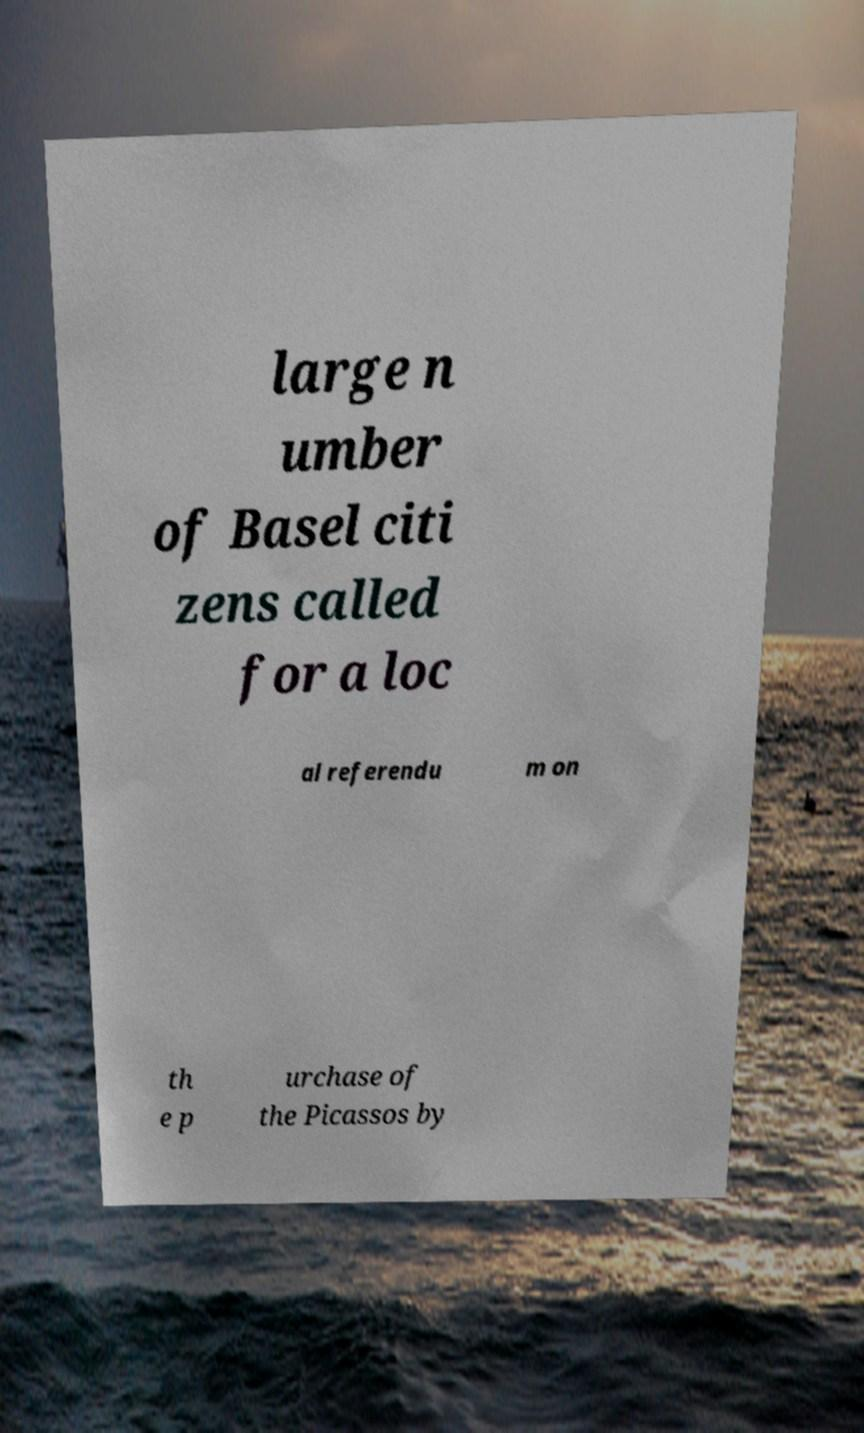Could you extract and type out the text from this image? large n umber of Basel citi zens called for a loc al referendu m on th e p urchase of the Picassos by 